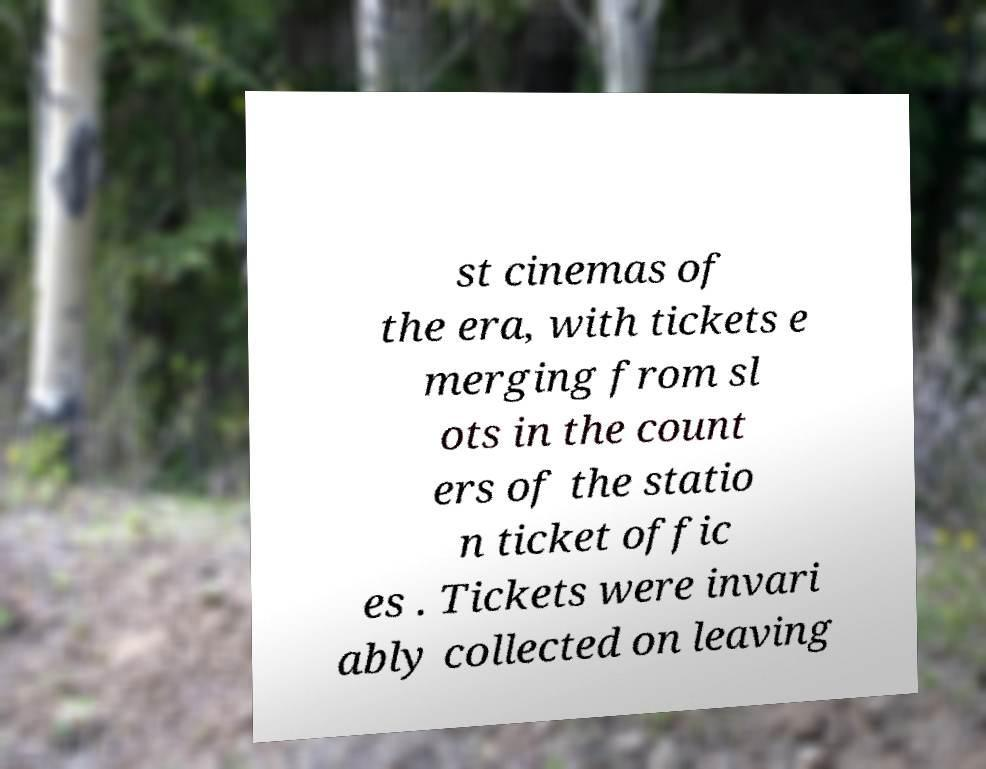Could you extract and type out the text from this image? st cinemas of the era, with tickets e merging from sl ots in the count ers of the statio n ticket offic es . Tickets were invari ably collected on leaving 